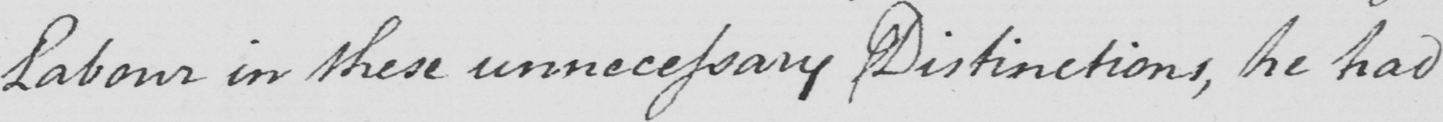What text is written in this handwritten line? Labour in these unnecessary Distinctions , he had 